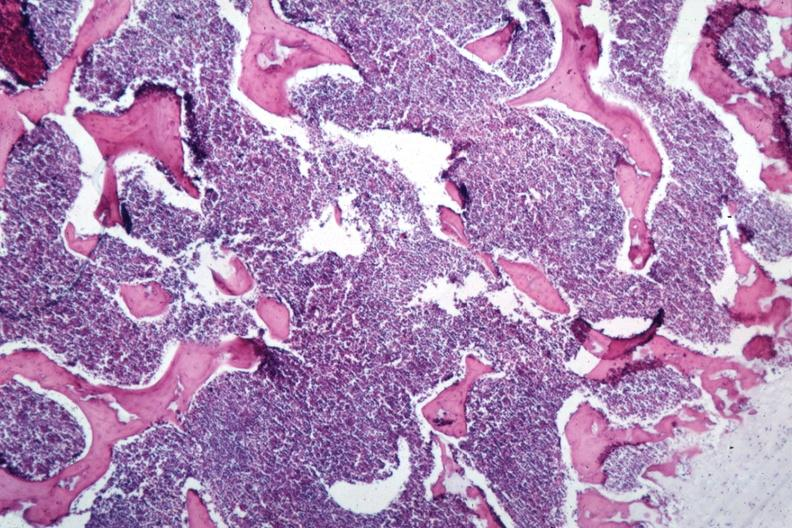s fallopian tube present?
Answer the question using a single word or phrase. No 